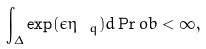Convert formula to latex. <formula><loc_0><loc_0><loc_500><loc_500>\int _ { \Delta } \exp ( \epsilon \eta _ { \ q } ) d \Pr o b < \infty ,</formula> 